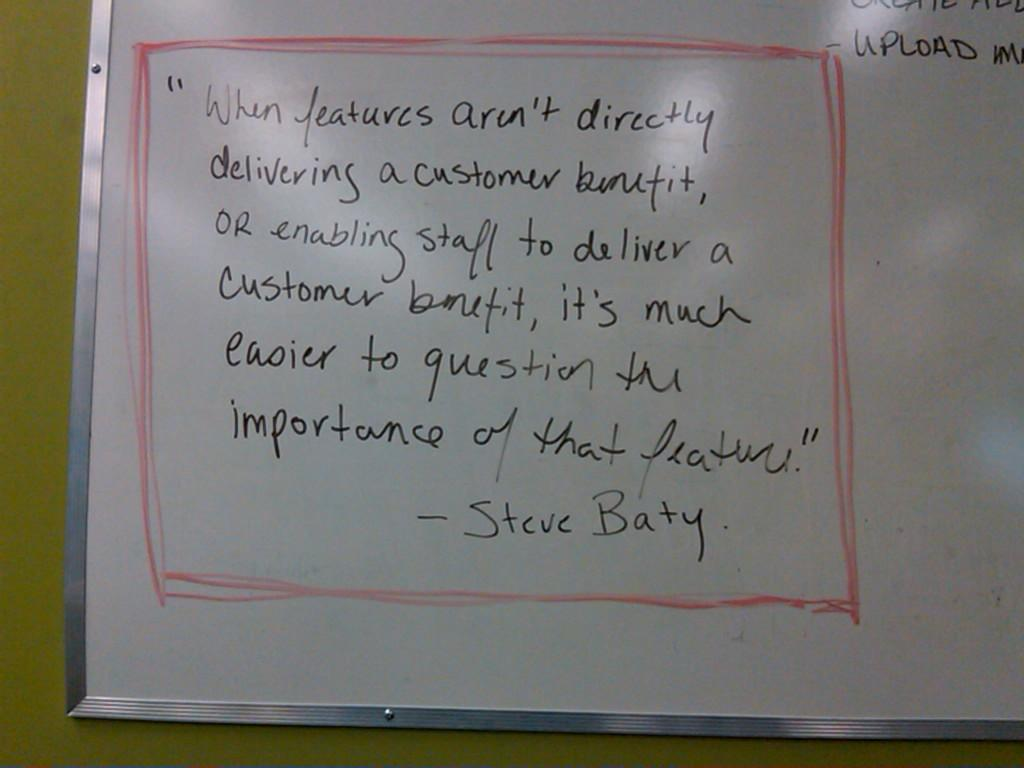<image>
Present a compact description of the photo's key features. A white board features a quote by Steve Baty. 